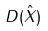<formula> <loc_0><loc_0><loc_500><loc_500>D ( \hat { X } )</formula> 